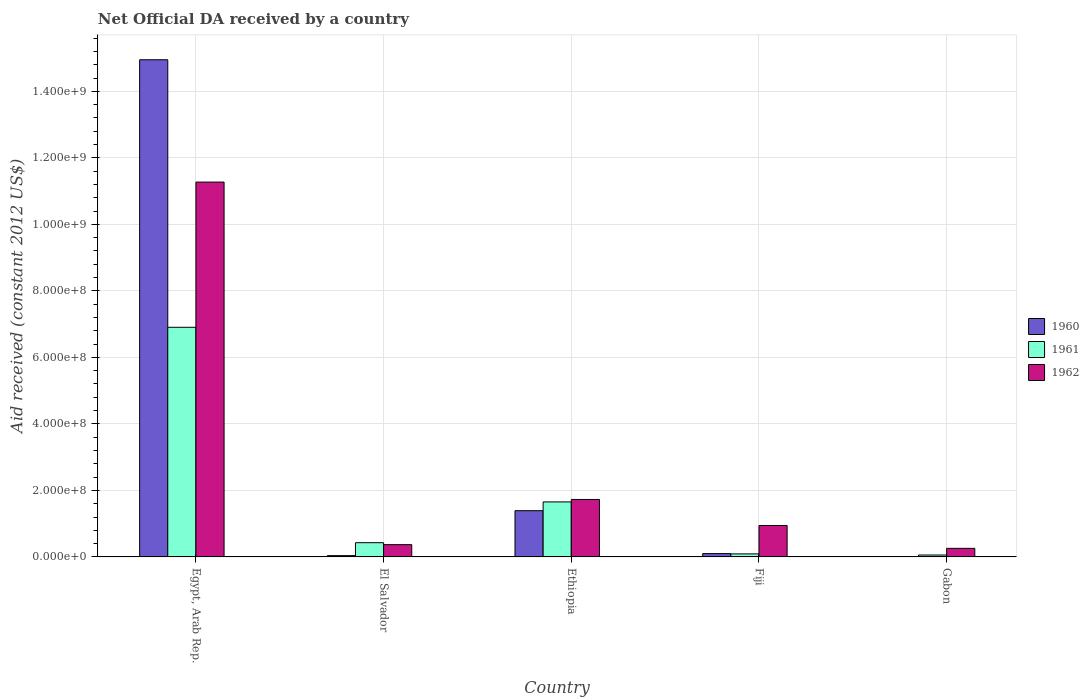Are the number of bars on each tick of the X-axis equal?
Your response must be concise. Yes. What is the label of the 3rd group of bars from the left?
Provide a succinct answer. Ethiopia. In how many cases, is the number of bars for a given country not equal to the number of legend labels?
Offer a terse response. 0. What is the net official development assistance aid received in 1962 in Gabon?
Offer a very short reply. 2.58e+07. Across all countries, what is the maximum net official development assistance aid received in 1960?
Your answer should be compact. 1.50e+09. Across all countries, what is the minimum net official development assistance aid received in 1960?
Your response must be concise. 1.90e+05. In which country was the net official development assistance aid received in 1962 maximum?
Provide a short and direct response. Egypt, Arab Rep. In which country was the net official development assistance aid received in 1960 minimum?
Offer a terse response. Gabon. What is the total net official development assistance aid received in 1961 in the graph?
Provide a short and direct response. 9.14e+08. What is the difference between the net official development assistance aid received in 1961 in Egypt, Arab Rep. and that in Ethiopia?
Keep it short and to the point. 5.25e+08. What is the difference between the net official development assistance aid received in 1962 in Fiji and the net official development assistance aid received in 1961 in El Salvador?
Keep it short and to the point. 5.18e+07. What is the average net official development assistance aid received in 1961 per country?
Offer a terse response. 1.83e+08. What is the difference between the net official development assistance aid received of/in 1962 and net official development assistance aid received of/in 1960 in Fiji?
Offer a very short reply. 8.46e+07. What is the ratio of the net official development assistance aid received in 1960 in Egypt, Arab Rep. to that in El Salvador?
Make the answer very short. 384.33. Is the difference between the net official development assistance aid received in 1962 in El Salvador and Ethiopia greater than the difference between the net official development assistance aid received in 1960 in El Salvador and Ethiopia?
Provide a short and direct response. No. What is the difference between the highest and the second highest net official development assistance aid received in 1961?
Your answer should be very brief. 5.25e+08. What is the difference between the highest and the lowest net official development assistance aid received in 1961?
Offer a very short reply. 6.85e+08. In how many countries, is the net official development assistance aid received in 1961 greater than the average net official development assistance aid received in 1961 taken over all countries?
Offer a very short reply. 1. Is the sum of the net official development assistance aid received in 1961 in Egypt, Arab Rep. and Ethiopia greater than the maximum net official development assistance aid received in 1962 across all countries?
Offer a very short reply. No. What does the 2nd bar from the left in Fiji represents?
Provide a succinct answer. 1961. Is it the case that in every country, the sum of the net official development assistance aid received in 1960 and net official development assistance aid received in 1962 is greater than the net official development assistance aid received in 1961?
Your answer should be compact. No. How many bars are there?
Offer a very short reply. 15. Are all the bars in the graph horizontal?
Offer a very short reply. No. What is the difference between two consecutive major ticks on the Y-axis?
Offer a terse response. 2.00e+08. Does the graph contain any zero values?
Ensure brevity in your answer.  No. Does the graph contain grids?
Give a very brief answer. Yes. Where does the legend appear in the graph?
Your answer should be very brief. Center right. What is the title of the graph?
Keep it short and to the point. Net Official DA received by a country. Does "1977" appear as one of the legend labels in the graph?
Your response must be concise. No. What is the label or title of the X-axis?
Ensure brevity in your answer.  Country. What is the label or title of the Y-axis?
Your answer should be very brief. Aid received (constant 2012 US$). What is the Aid received (constant 2012 US$) of 1960 in Egypt, Arab Rep.?
Your response must be concise. 1.50e+09. What is the Aid received (constant 2012 US$) in 1961 in Egypt, Arab Rep.?
Offer a very short reply. 6.91e+08. What is the Aid received (constant 2012 US$) of 1962 in Egypt, Arab Rep.?
Provide a short and direct response. 1.13e+09. What is the Aid received (constant 2012 US$) of 1960 in El Salvador?
Offer a very short reply. 3.89e+06. What is the Aid received (constant 2012 US$) in 1961 in El Salvador?
Offer a very short reply. 4.28e+07. What is the Aid received (constant 2012 US$) in 1962 in El Salvador?
Provide a short and direct response. 3.69e+07. What is the Aid received (constant 2012 US$) in 1960 in Ethiopia?
Offer a terse response. 1.39e+08. What is the Aid received (constant 2012 US$) in 1961 in Ethiopia?
Offer a very short reply. 1.65e+08. What is the Aid received (constant 2012 US$) in 1962 in Ethiopia?
Ensure brevity in your answer.  1.73e+08. What is the Aid received (constant 2012 US$) of 1960 in Fiji?
Give a very brief answer. 1.00e+07. What is the Aid received (constant 2012 US$) in 1961 in Fiji?
Your answer should be very brief. 9.09e+06. What is the Aid received (constant 2012 US$) in 1962 in Fiji?
Your response must be concise. 9.46e+07. What is the Aid received (constant 2012 US$) in 1961 in Gabon?
Keep it short and to the point. 5.73e+06. What is the Aid received (constant 2012 US$) of 1962 in Gabon?
Keep it short and to the point. 2.58e+07. Across all countries, what is the maximum Aid received (constant 2012 US$) of 1960?
Ensure brevity in your answer.  1.50e+09. Across all countries, what is the maximum Aid received (constant 2012 US$) in 1961?
Offer a very short reply. 6.91e+08. Across all countries, what is the maximum Aid received (constant 2012 US$) in 1962?
Offer a terse response. 1.13e+09. Across all countries, what is the minimum Aid received (constant 2012 US$) in 1961?
Make the answer very short. 5.73e+06. Across all countries, what is the minimum Aid received (constant 2012 US$) in 1962?
Keep it short and to the point. 2.58e+07. What is the total Aid received (constant 2012 US$) in 1960 in the graph?
Keep it short and to the point. 1.65e+09. What is the total Aid received (constant 2012 US$) of 1961 in the graph?
Make the answer very short. 9.14e+08. What is the total Aid received (constant 2012 US$) in 1962 in the graph?
Make the answer very short. 1.46e+09. What is the difference between the Aid received (constant 2012 US$) in 1960 in Egypt, Arab Rep. and that in El Salvador?
Provide a succinct answer. 1.49e+09. What is the difference between the Aid received (constant 2012 US$) of 1961 in Egypt, Arab Rep. and that in El Salvador?
Keep it short and to the point. 6.48e+08. What is the difference between the Aid received (constant 2012 US$) in 1962 in Egypt, Arab Rep. and that in El Salvador?
Provide a short and direct response. 1.09e+09. What is the difference between the Aid received (constant 2012 US$) of 1960 in Egypt, Arab Rep. and that in Ethiopia?
Provide a succinct answer. 1.36e+09. What is the difference between the Aid received (constant 2012 US$) of 1961 in Egypt, Arab Rep. and that in Ethiopia?
Provide a succinct answer. 5.25e+08. What is the difference between the Aid received (constant 2012 US$) of 1962 in Egypt, Arab Rep. and that in Ethiopia?
Offer a very short reply. 9.54e+08. What is the difference between the Aid received (constant 2012 US$) in 1960 in Egypt, Arab Rep. and that in Fiji?
Ensure brevity in your answer.  1.49e+09. What is the difference between the Aid received (constant 2012 US$) of 1961 in Egypt, Arab Rep. and that in Fiji?
Offer a terse response. 6.81e+08. What is the difference between the Aid received (constant 2012 US$) of 1962 in Egypt, Arab Rep. and that in Fiji?
Provide a short and direct response. 1.03e+09. What is the difference between the Aid received (constant 2012 US$) in 1960 in Egypt, Arab Rep. and that in Gabon?
Ensure brevity in your answer.  1.49e+09. What is the difference between the Aid received (constant 2012 US$) of 1961 in Egypt, Arab Rep. and that in Gabon?
Provide a short and direct response. 6.85e+08. What is the difference between the Aid received (constant 2012 US$) of 1962 in Egypt, Arab Rep. and that in Gabon?
Your answer should be very brief. 1.10e+09. What is the difference between the Aid received (constant 2012 US$) in 1960 in El Salvador and that in Ethiopia?
Give a very brief answer. -1.35e+08. What is the difference between the Aid received (constant 2012 US$) of 1961 in El Salvador and that in Ethiopia?
Keep it short and to the point. -1.23e+08. What is the difference between the Aid received (constant 2012 US$) of 1962 in El Salvador and that in Ethiopia?
Ensure brevity in your answer.  -1.36e+08. What is the difference between the Aid received (constant 2012 US$) of 1960 in El Salvador and that in Fiji?
Provide a short and direct response. -6.12e+06. What is the difference between the Aid received (constant 2012 US$) in 1961 in El Salvador and that in Fiji?
Provide a succinct answer. 3.37e+07. What is the difference between the Aid received (constant 2012 US$) of 1962 in El Salvador and that in Fiji?
Offer a very short reply. -5.77e+07. What is the difference between the Aid received (constant 2012 US$) in 1960 in El Salvador and that in Gabon?
Ensure brevity in your answer.  3.70e+06. What is the difference between the Aid received (constant 2012 US$) of 1961 in El Salvador and that in Gabon?
Offer a terse response. 3.70e+07. What is the difference between the Aid received (constant 2012 US$) in 1962 in El Salvador and that in Gabon?
Your response must be concise. 1.11e+07. What is the difference between the Aid received (constant 2012 US$) in 1960 in Ethiopia and that in Fiji?
Offer a terse response. 1.29e+08. What is the difference between the Aid received (constant 2012 US$) of 1961 in Ethiopia and that in Fiji?
Offer a terse response. 1.56e+08. What is the difference between the Aid received (constant 2012 US$) of 1962 in Ethiopia and that in Fiji?
Give a very brief answer. 7.82e+07. What is the difference between the Aid received (constant 2012 US$) of 1960 in Ethiopia and that in Gabon?
Your answer should be compact. 1.39e+08. What is the difference between the Aid received (constant 2012 US$) of 1961 in Ethiopia and that in Gabon?
Ensure brevity in your answer.  1.60e+08. What is the difference between the Aid received (constant 2012 US$) in 1962 in Ethiopia and that in Gabon?
Keep it short and to the point. 1.47e+08. What is the difference between the Aid received (constant 2012 US$) of 1960 in Fiji and that in Gabon?
Your answer should be compact. 9.82e+06. What is the difference between the Aid received (constant 2012 US$) of 1961 in Fiji and that in Gabon?
Your answer should be very brief. 3.36e+06. What is the difference between the Aid received (constant 2012 US$) in 1962 in Fiji and that in Gabon?
Offer a very short reply. 6.88e+07. What is the difference between the Aid received (constant 2012 US$) in 1960 in Egypt, Arab Rep. and the Aid received (constant 2012 US$) in 1961 in El Salvador?
Offer a very short reply. 1.45e+09. What is the difference between the Aid received (constant 2012 US$) of 1960 in Egypt, Arab Rep. and the Aid received (constant 2012 US$) of 1962 in El Salvador?
Offer a terse response. 1.46e+09. What is the difference between the Aid received (constant 2012 US$) of 1961 in Egypt, Arab Rep. and the Aid received (constant 2012 US$) of 1962 in El Salvador?
Offer a very short reply. 6.54e+08. What is the difference between the Aid received (constant 2012 US$) of 1960 in Egypt, Arab Rep. and the Aid received (constant 2012 US$) of 1961 in Ethiopia?
Ensure brevity in your answer.  1.33e+09. What is the difference between the Aid received (constant 2012 US$) of 1960 in Egypt, Arab Rep. and the Aid received (constant 2012 US$) of 1962 in Ethiopia?
Your response must be concise. 1.32e+09. What is the difference between the Aid received (constant 2012 US$) of 1961 in Egypt, Arab Rep. and the Aid received (constant 2012 US$) of 1962 in Ethiopia?
Provide a short and direct response. 5.18e+08. What is the difference between the Aid received (constant 2012 US$) in 1960 in Egypt, Arab Rep. and the Aid received (constant 2012 US$) in 1961 in Fiji?
Keep it short and to the point. 1.49e+09. What is the difference between the Aid received (constant 2012 US$) in 1960 in Egypt, Arab Rep. and the Aid received (constant 2012 US$) in 1962 in Fiji?
Your response must be concise. 1.40e+09. What is the difference between the Aid received (constant 2012 US$) of 1961 in Egypt, Arab Rep. and the Aid received (constant 2012 US$) of 1962 in Fiji?
Ensure brevity in your answer.  5.96e+08. What is the difference between the Aid received (constant 2012 US$) of 1960 in Egypt, Arab Rep. and the Aid received (constant 2012 US$) of 1961 in Gabon?
Offer a very short reply. 1.49e+09. What is the difference between the Aid received (constant 2012 US$) of 1960 in Egypt, Arab Rep. and the Aid received (constant 2012 US$) of 1962 in Gabon?
Ensure brevity in your answer.  1.47e+09. What is the difference between the Aid received (constant 2012 US$) in 1961 in Egypt, Arab Rep. and the Aid received (constant 2012 US$) in 1962 in Gabon?
Keep it short and to the point. 6.65e+08. What is the difference between the Aid received (constant 2012 US$) of 1960 in El Salvador and the Aid received (constant 2012 US$) of 1961 in Ethiopia?
Your answer should be compact. -1.62e+08. What is the difference between the Aid received (constant 2012 US$) in 1960 in El Salvador and the Aid received (constant 2012 US$) in 1962 in Ethiopia?
Ensure brevity in your answer.  -1.69e+08. What is the difference between the Aid received (constant 2012 US$) of 1961 in El Salvador and the Aid received (constant 2012 US$) of 1962 in Ethiopia?
Make the answer very short. -1.30e+08. What is the difference between the Aid received (constant 2012 US$) of 1960 in El Salvador and the Aid received (constant 2012 US$) of 1961 in Fiji?
Offer a terse response. -5.20e+06. What is the difference between the Aid received (constant 2012 US$) in 1960 in El Salvador and the Aid received (constant 2012 US$) in 1962 in Fiji?
Your answer should be very brief. -9.07e+07. What is the difference between the Aid received (constant 2012 US$) of 1961 in El Salvador and the Aid received (constant 2012 US$) of 1962 in Fiji?
Provide a short and direct response. -5.18e+07. What is the difference between the Aid received (constant 2012 US$) in 1960 in El Salvador and the Aid received (constant 2012 US$) in 1961 in Gabon?
Provide a succinct answer. -1.84e+06. What is the difference between the Aid received (constant 2012 US$) of 1960 in El Salvador and the Aid received (constant 2012 US$) of 1962 in Gabon?
Keep it short and to the point. -2.19e+07. What is the difference between the Aid received (constant 2012 US$) of 1961 in El Salvador and the Aid received (constant 2012 US$) of 1962 in Gabon?
Ensure brevity in your answer.  1.70e+07. What is the difference between the Aid received (constant 2012 US$) of 1960 in Ethiopia and the Aid received (constant 2012 US$) of 1961 in Fiji?
Your answer should be compact. 1.30e+08. What is the difference between the Aid received (constant 2012 US$) of 1960 in Ethiopia and the Aid received (constant 2012 US$) of 1962 in Fiji?
Offer a terse response. 4.44e+07. What is the difference between the Aid received (constant 2012 US$) in 1961 in Ethiopia and the Aid received (constant 2012 US$) in 1962 in Fiji?
Make the answer very short. 7.08e+07. What is the difference between the Aid received (constant 2012 US$) of 1960 in Ethiopia and the Aid received (constant 2012 US$) of 1961 in Gabon?
Offer a terse response. 1.33e+08. What is the difference between the Aid received (constant 2012 US$) in 1960 in Ethiopia and the Aid received (constant 2012 US$) in 1962 in Gabon?
Provide a short and direct response. 1.13e+08. What is the difference between the Aid received (constant 2012 US$) of 1961 in Ethiopia and the Aid received (constant 2012 US$) of 1962 in Gabon?
Offer a very short reply. 1.40e+08. What is the difference between the Aid received (constant 2012 US$) in 1960 in Fiji and the Aid received (constant 2012 US$) in 1961 in Gabon?
Your response must be concise. 4.28e+06. What is the difference between the Aid received (constant 2012 US$) of 1960 in Fiji and the Aid received (constant 2012 US$) of 1962 in Gabon?
Ensure brevity in your answer.  -1.58e+07. What is the difference between the Aid received (constant 2012 US$) of 1961 in Fiji and the Aid received (constant 2012 US$) of 1962 in Gabon?
Ensure brevity in your answer.  -1.67e+07. What is the average Aid received (constant 2012 US$) in 1960 per country?
Offer a terse response. 3.30e+08. What is the average Aid received (constant 2012 US$) in 1961 per country?
Offer a terse response. 1.83e+08. What is the average Aid received (constant 2012 US$) in 1962 per country?
Give a very brief answer. 2.91e+08. What is the difference between the Aid received (constant 2012 US$) in 1960 and Aid received (constant 2012 US$) in 1961 in Egypt, Arab Rep.?
Give a very brief answer. 8.05e+08. What is the difference between the Aid received (constant 2012 US$) in 1960 and Aid received (constant 2012 US$) in 1962 in Egypt, Arab Rep.?
Keep it short and to the point. 3.68e+08. What is the difference between the Aid received (constant 2012 US$) of 1961 and Aid received (constant 2012 US$) of 1962 in Egypt, Arab Rep.?
Ensure brevity in your answer.  -4.37e+08. What is the difference between the Aid received (constant 2012 US$) of 1960 and Aid received (constant 2012 US$) of 1961 in El Salvador?
Provide a succinct answer. -3.89e+07. What is the difference between the Aid received (constant 2012 US$) in 1960 and Aid received (constant 2012 US$) in 1962 in El Salvador?
Your answer should be compact. -3.30e+07. What is the difference between the Aid received (constant 2012 US$) in 1961 and Aid received (constant 2012 US$) in 1962 in El Salvador?
Give a very brief answer. 5.86e+06. What is the difference between the Aid received (constant 2012 US$) of 1960 and Aid received (constant 2012 US$) of 1961 in Ethiopia?
Your response must be concise. -2.64e+07. What is the difference between the Aid received (constant 2012 US$) in 1960 and Aid received (constant 2012 US$) in 1962 in Ethiopia?
Offer a terse response. -3.38e+07. What is the difference between the Aid received (constant 2012 US$) in 1961 and Aid received (constant 2012 US$) in 1962 in Ethiopia?
Your answer should be very brief. -7.39e+06. What is the difference between the Aid received (constant 2012 US$) of 1960 and Aid received (constant 2012 US$) of 1961 in Fiji?
Make the answer very short. 9.20e+05. What is the difference between the Aid received (constant 2012 US$) in 1960 and Aid received (constant 2012 US$) in 1962 in Fiji?
Ensure brevity in your answer.  -8.46e+07. What is the difference between the Aid received (constant 2012 US$) of 1961 and Aid received (constant 2012 US$) of 1962 in Fiji?
Your answer should be very brief. -8.55e+07. What is the difference between the Aid received (constant 2012 US$) of 1960 and Aid received (constant 2012 US$) of 1961 in Gabon?
Your response must be concise. -5.54e+06. What is the difference between the Aid received (constant 2012 US$) in 1960 and Aid received (constant 2012 US$) in 1962 in Gabon?
Offer a terse response. -2.56e+07. What is the difference between the Aid received (constant 2012 US$) in 1961 and Aid received (constant 2012 US$) in 1962 in Gabon?
Your answer should be very brief. -2.01e+07. What is the ratio of the Aid received (constant 2012 US$) of 1960 in Egypt, Arab Rep. to that in El Salvador?
Provide a short and direct response. 384.33. What is the ratio of the Aid received (constant 2012 US$) in 1961 in Egypt, Arab Rep. to that in El Salvador?
Offer a very short reply. 16.14. What is the ratio of the Aid received (constant 2012 US$) of 1962 in Egypt, Arab Rep. to that in El Salvador?
Your answer should be compact. 30.53. What is the ratio of the Aid received (constant 2012 US$) in 1960 in Egypt, Arab Rep. to that in Ethiopia?
Give a very brief answer. 10.75. What is the ratio of the Aid received (constant 2012 US$) in 1961 in Egypt, Arab Rep. to that in Ethiopia?
Ensure brevity in your answer.  4.17. What is the ratio of the Aid received (constant 2012 US$) in 1962 in Egypt, Arab Rep. to that in Ethiopia?
Give a very brief answer. 6.52. What is the ratio of the Aid received (constant 2012 US$) of 1960 in Egypt, Arab Rep. to that in Fiji?
Provide a short and direct response. 149.36. What is the ratio of the Aid received (constant 2012 US$) in 1961 in Egypt, Arab Rep. to that in Fiji?
Your answer should be very brief. 75.96. What is the ratio of the Aid received (constant 2012 US$) in 1962 in Egypt, Arab Rep. to that in Fiji?
Offer a very short reply. 11.91. What is the ratio of the Aid received (constant 2012 US$) of 1960 in Egypt, Arab Rep. to that in Gabon?
Ensure brevity in your answer.  7868.74. What is the ratio of the Aid received (constant 2012 US$) of 1961 in Egypt, Arab Rep. to that in Gabon?
Keep it short and to the point. 120.51. What is the ratio of the Aid received (constant 2012 US$) of 1962 in Egypt, Arab Rep. to that in Gabon?
Offer a terse response. 43.69. What is the ratio of the Aid received (constant 2012 US$) of 1960 in El Salvador to that in Ethiopia?
Keep it short and to the point. 0.03. What is the ratio of the Aid received (constant 2012 US$) of 1961 in El Salvador to that in Ethiopia?
Your response must be concise. 0.26. What is the ratio of the Aid received (constant 2012 US$) in 1962 in El Salvador to that in Ethiopia?
Ensure brevity in your answer.  0.21. What is the ratio of the Aid received (constant 2012 US$) in 1960 in El Salvador to that in Fiji?
Offer a very short reply. 0.39. What is the ratio of the Aid received (constant 2012 US$) in 1961 in El Salvador to that in Fiji?
Give a very brief answer. 4.71. What is the ratio of the Aid received (constant 2012 US$) of 1962 in El Salvador to that in Fiji?
Offer a terse response. 0.39. What is the ratio of the Aid received (constant 2012 US$) in 1960 in El Salvador to that in Gabon?
Provide a short and direct response. 20.47. What is the ratio of the Aid received (constant 2012 US$) of 1961 in El Salvador to that in Gabon?
Make the answer very short. 7.47. What is the ratio of the Aid received (constant 2012 US$) in 1962 in El Salvador to that in Gabon?
Make the answer very short. 1.43. What is the ratio of the Aid received (constant 2012 US$) in 1960 in Ethiopia to that in Fiji?
Keep it short and to the point. 13.89. What is the ratio of the Aid received (constant 2012 US$) in 1961 in Ethiopia to that in Fiji?
Your answer should be very brief. 18.2. What is the ratio of the Aid received (constant 2012 US$) in 1962 in Ethiopia to that in Fiji?
Provide a short and direct response. 1.83. What is the ratio of the Aid received (constant 2012 US$) in 1960 in Ethiopia to that in Gabon?
Offer a very short reply. 731.74. What is the ratio of the Aid received (constant 2012 US$) of 1961 in Ethiopia to that in Gabon?
Give a very brief answer. 28.87. What is the ratio of the Aid received (constant 2012 US$) in 1962 in Ethiopia to that in Gabon?
Ensure brevity in your answer.  6.7. What is the ratio of the Aid received (constant 2012 US$) in 1960 in Fiji to that in Gabon?
Give a very brief answer. 52.68. What is the ratio of the Aid received (constant 2012 US$) of 1961 in Fiji to that in Gabon?
Provide a short and direct response. 1.59. What is the ratio of the Aid received (constant 2012 US$) of 1962 in Fiji to that in Gabon?
Ensure brevity in your answer.  3.67. What is the difference between the highest and the second highest Aid received (constant 2012 US$) in 1960?
Ensure brevity in your answer.  1.36e+09. What is the difference between the highest and the second highest Aid received (constant 2012 US$) of 1961?
Provide a succinct answer. 5.25e+08. What is the difference between the highest and the second highest Aid received (constant 2012 US$) in 1962?
Your response must be concise. 9.54e+08. What is the difference between the highest and the lowest Aid received (constant 2012 US$) in 1960?
Your answer should be very brief. 1.49e+09. What is the difference between the highest and the lowest Aid received (constant 2012 US$) of 1961?
Your answer should be very brief. 6.85e+08. What is the difference between the highest and the lowest Aid received (constant 2012 US$) of 1962?
Provide a succinct answer. 1.10e+09. 